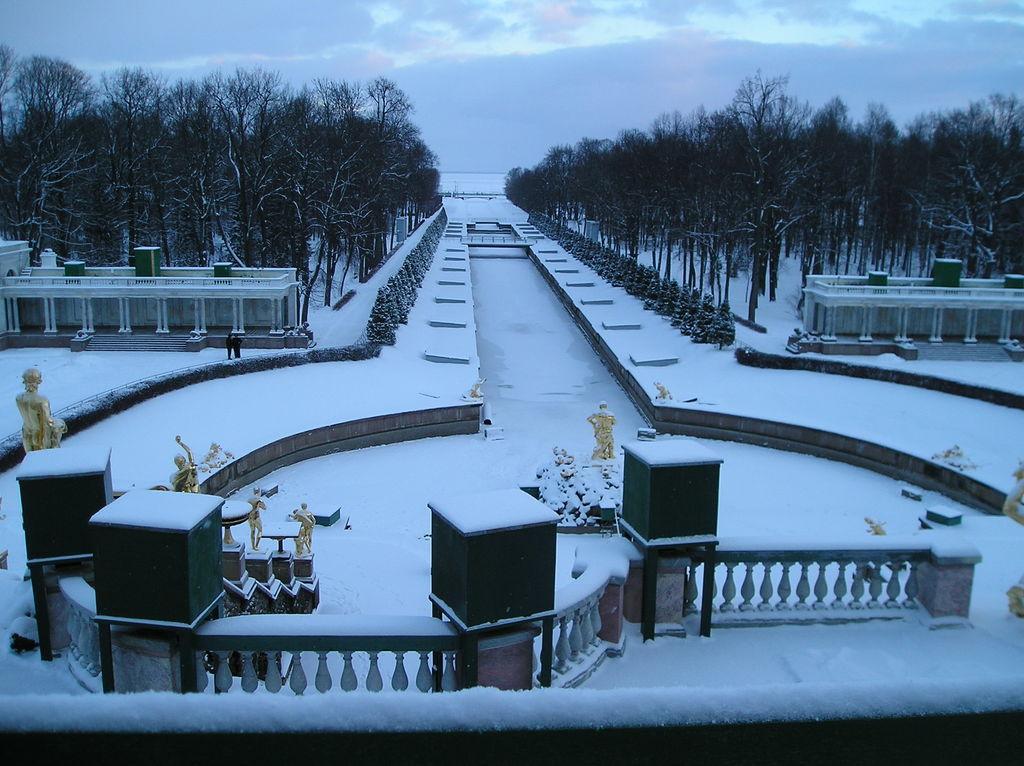In one or two sentences, can you explain what this image depicts? In this picture I can see the railing and the snow at the bottom, in the middle there are statues. There are trees on either side of this image, at the top there is the sky. 